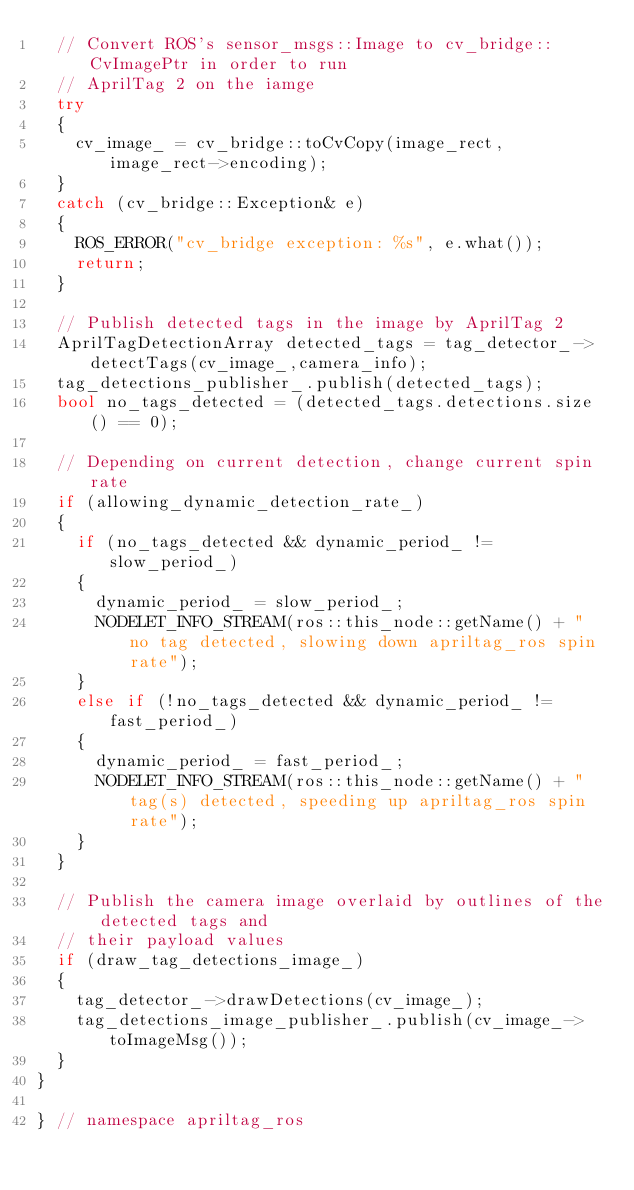Convert code to text. <code><loc_0><loc_0><loc_500><loc_500><_C++_>  // Convert ROS's sensor_msgs::Image to cv_bridge::CvImagePtr in order to run
  // AprilTag 2 on the iamge
  try
  {
    cv_image_ = cv_bridge::toCvCopy(image_rect, image_rect->encoding);
  }
  catch (cv_bridge::Exception& e)
  {
    ROS_ERROR("cv_bridge exception: %s", e.what());
    return;
  }

  // Publish detected tags in the image by AprilTag 2
  AprilTagDetectionArray detected_tags = tag_detector_->detectTags(cv_image_,camera_info);
  tag_detections_publisher_.publish(detected_tags);
  bool no_tags_detected = (detected_tags.detections.size() == 0);

  // Depending on current detection, change current spin rate
  if (allowing_dynamic_detection_rate_)
  {
    if (no_tags_detected && dynamic_period_ != slow_period_)
    {
      dynamic_period_ = slow_period_;
      NODELET_INFO_STREAM(ros::this_node::getName() + " no tag detected, slowing down apriltag_ros spin rate");
    }
    else if (!no_tags_detected && dynamic_period_ != fast_period_)
    {
      dynamic_period_ = fast_period_;
      NODELET_INFO_STREAM(ros::this_node::getName() + " tag(s) detected, speeding up apriltag_ros spin rate");
    }
  }

  // Publish the camera image overlaid by outlines of the detected tags and
  // their payload values
  if (draw_tag_detections_image_)
  {
    tag_detector_->drawDetections(cv_image_);
    tag_detections_image_publisher_.publish(cv_image_->toImageMsg());
  }
}

} // namespace apriltag_ros
</code> 